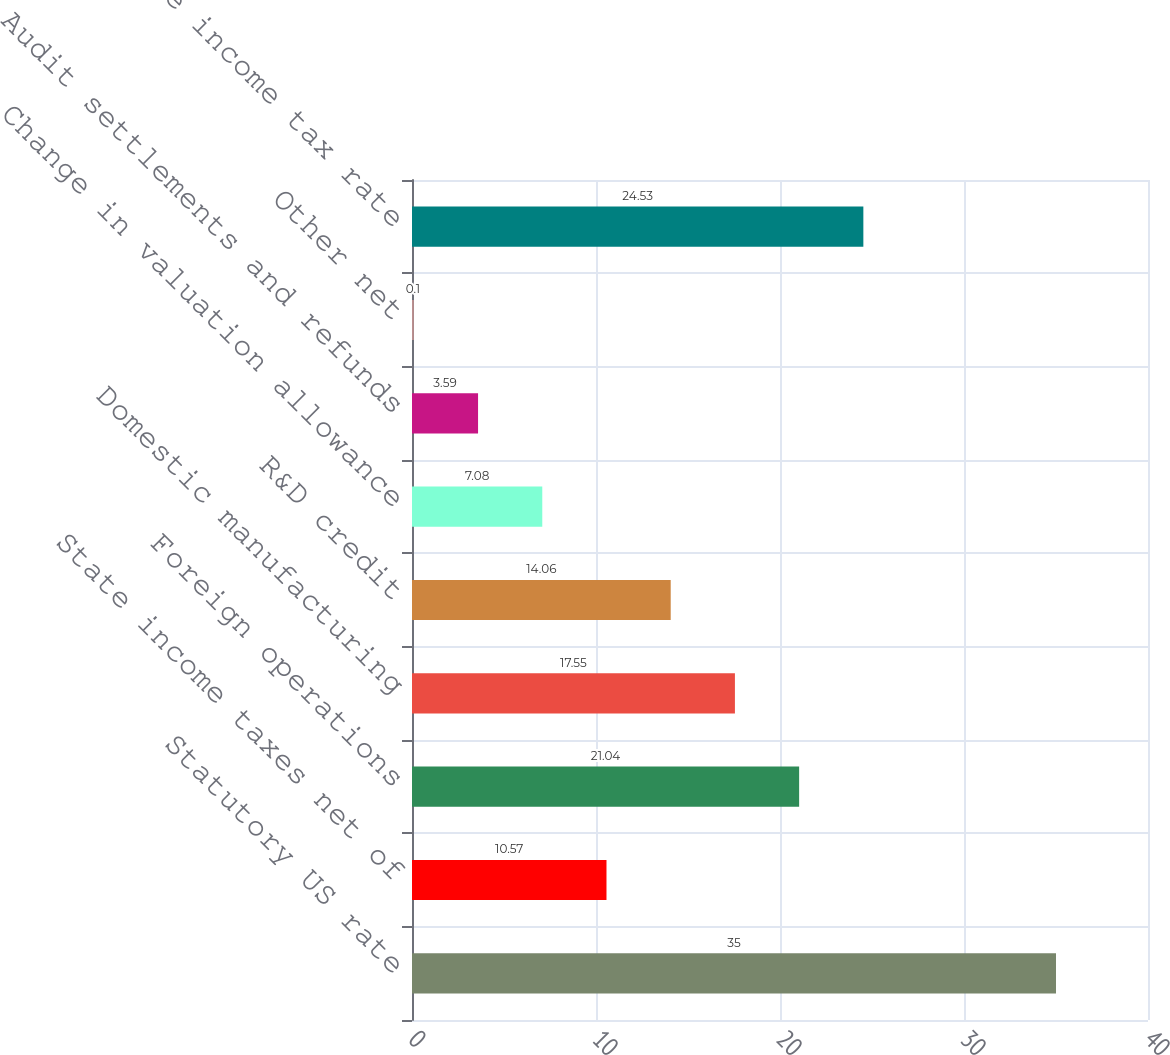Convert chart. <chart><loc_0><loc_0><loc_500><loc_500><bar_chart><fcel>Statutory US rate<fcel>State income taxes net of<fcel>Foreign operations<fcel>Domestic manufacturing<fcel>R&D credit<fcel>Change in valuation allowance<fcel>Audit settlements and refunds<fcel>Other net<fcel>Effective income tax rate<nl><fcel>35<fcel>10.57<fcel>21.04<fcel>17.55<fcel>14.06<fcel>7.08<fcel>3.59<fcel>0.1<fcel>24.53<nl></chart> 